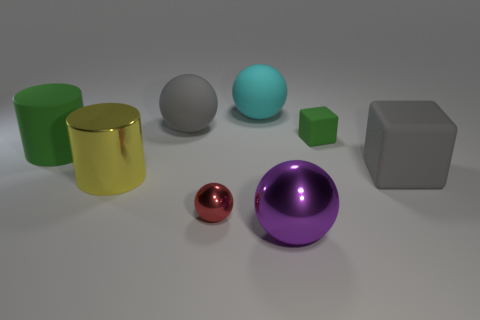Subtract all big balls. How many balls are left? 1 Add 1 large cyan matte objects. How many objects exist? 9 Subtract all cyan spheres. How many spheres are left? 3 Subtract all cubes. How many objects are left? 6 Subtract all cyan blocks. Subtract all gray spheres. How many blocks are left? 2 Subtract all cylinders. Subtract all blue rubber blocks. How many objects are left? 6 Add 3 big cyan objects. How many big cyan objects are left? 4 Add 1 rubber cubes. How many rubber cubes exist? 3 Subtract 0 cyan cylinders. How many objects are left? 8 